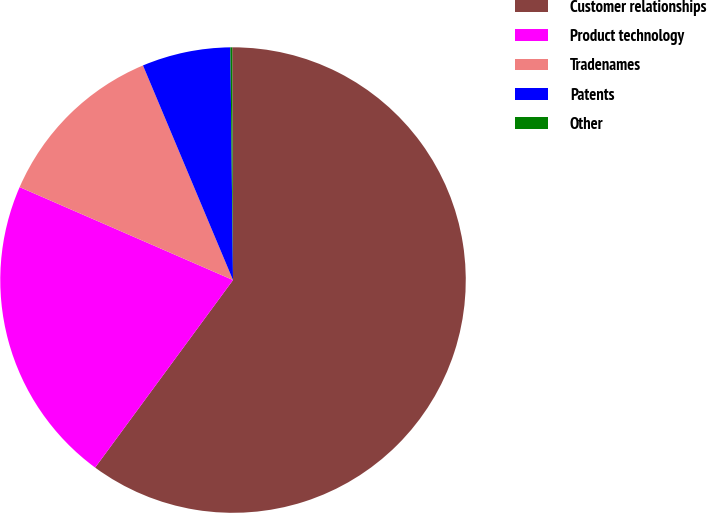<chart> <loc_0><loc_0><loc_500><loc_500><pie_chart><fcel>Customer relationships<fcel>Product technology<fcel>Tradenames<fcel>Patents<fcel>Other<nl><fcel>60.15%<fcel>21.45%<fcel>12.14%<fcel>6.14%<fcel>0.13%<nl></chart> 